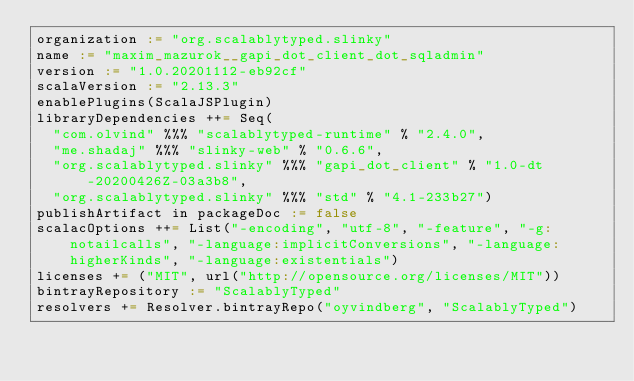<code> <loc_0><loc_0><loc_500><loc_500><_Scala_>organization := "org.scalablytyped.slinky"
name := "maxim_mazurok__gapi_dot_client_dot_sqladmin"
version := "1.0.20201112-eb92cf"
scalaVersion := "2.13.3"
enablePlugins(ScalaJSPlugin)
libraryDependencies ++= Seq(
  "com.olvind" %%% "scalablytyped-runtime" % "2.4.0",
  "me.shadaj" %%% "slinky-web" % "0.6.6",
  "org.scalablytyped.slinky" %%% "gapi_dot_client" % "1.0-dt-20200426Z-03a3b8",
  "org.scalablytyped.slinky" %%% "std" % "4.1-233b27")
publishArtifact in packageDoc := false
scalacOptions ++= List("-encoding", "utf-8", "-feature", "-g:notailcalls", "-language:implicitConversions", "-language:higherKinds", "-language:existentials")
licenses += ("MIT", url("http://opensource.org/licenses/MIT"))
bintrayRepository := "ScalablyTyped"
resolvers += Resolver.bintrayRepo("oyvindberg", "ScalablyTyped")
</code> 